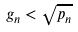Convert formula to latex. <formula><loc_0><loc_0><loc_500><loc_500>g _ { n } < \sqrt { p _ { n } }</formula> 